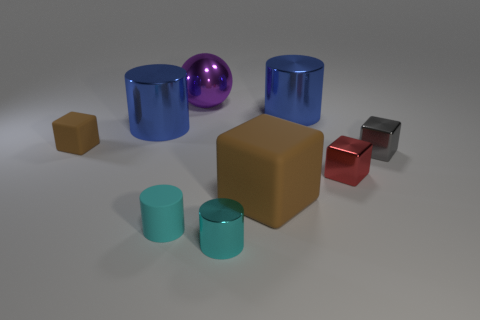Are there more tiny metallic cubes than big red matte cubes?
Give a very brief answer. Yes. There is a rubber cube on the right side of the brown cube that is on the left side of the cyan cylinder that is on the left side of the small cyan metal thing; what color is it?
Give a very brief answer. Brown. There is a tiny metallic thing that is in front of the big block; is it the same color as the big shiny thing to the left of the big purple object?
Offer a terse response. No. How many large blue cylinders are to the left of the brown block that is behind the large brown rubber object?
Provide a short and direct response. 0. Are there any tiny rubber cylinders?
Your answer should be very brief. Yes. What number of other objects are there of the same color as the large block?
Give a very brief answer. 1. Is the number of brown cubes less than the number of red things?
Your answer should be compact. No. What is the shape of the blue object that is on the right side of the metal sphere that is behind the red thing?
Make the answer very short. Cylinder. Are there any gray shiny things in front of the gray object?
Your answer should be compact. No. What color is the other metal cube that is the same size as the gray metallic cube?
Your answer should be very brief. Red. 